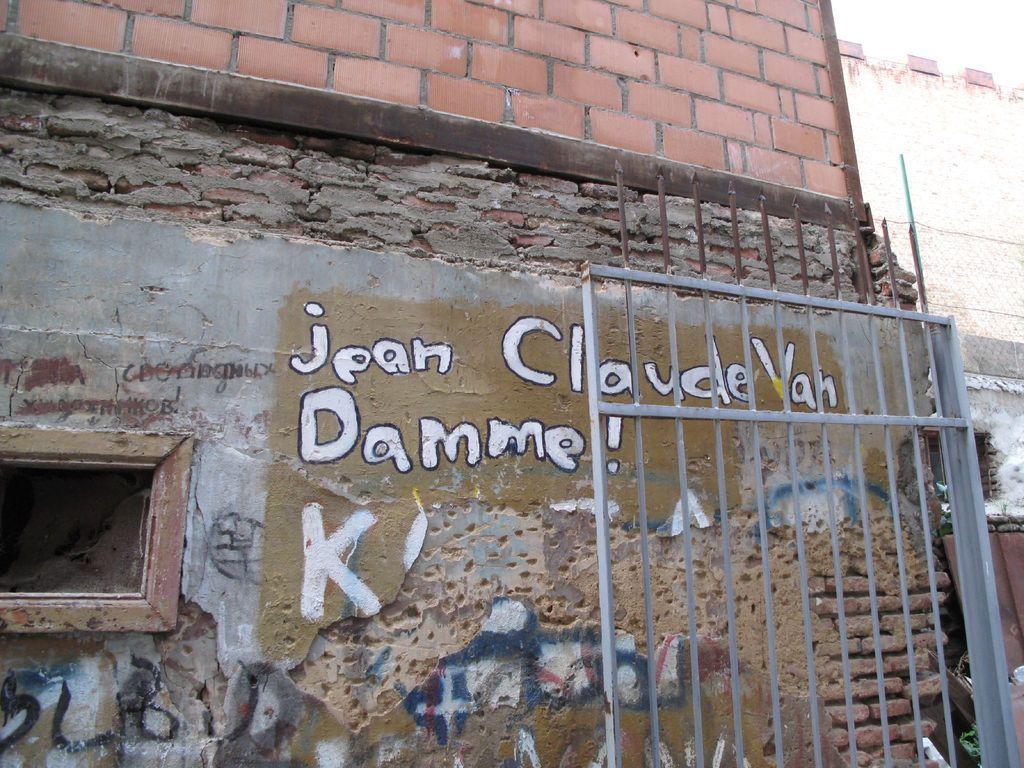In one or two sentences, can you explain what this image depicts? In this picture there is a building in the center of the image and there is a gate on the right side of the image. 